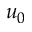<formula> <loc_0><loc_0><loc_500><loc_500>u _ { 0 }</formula> 